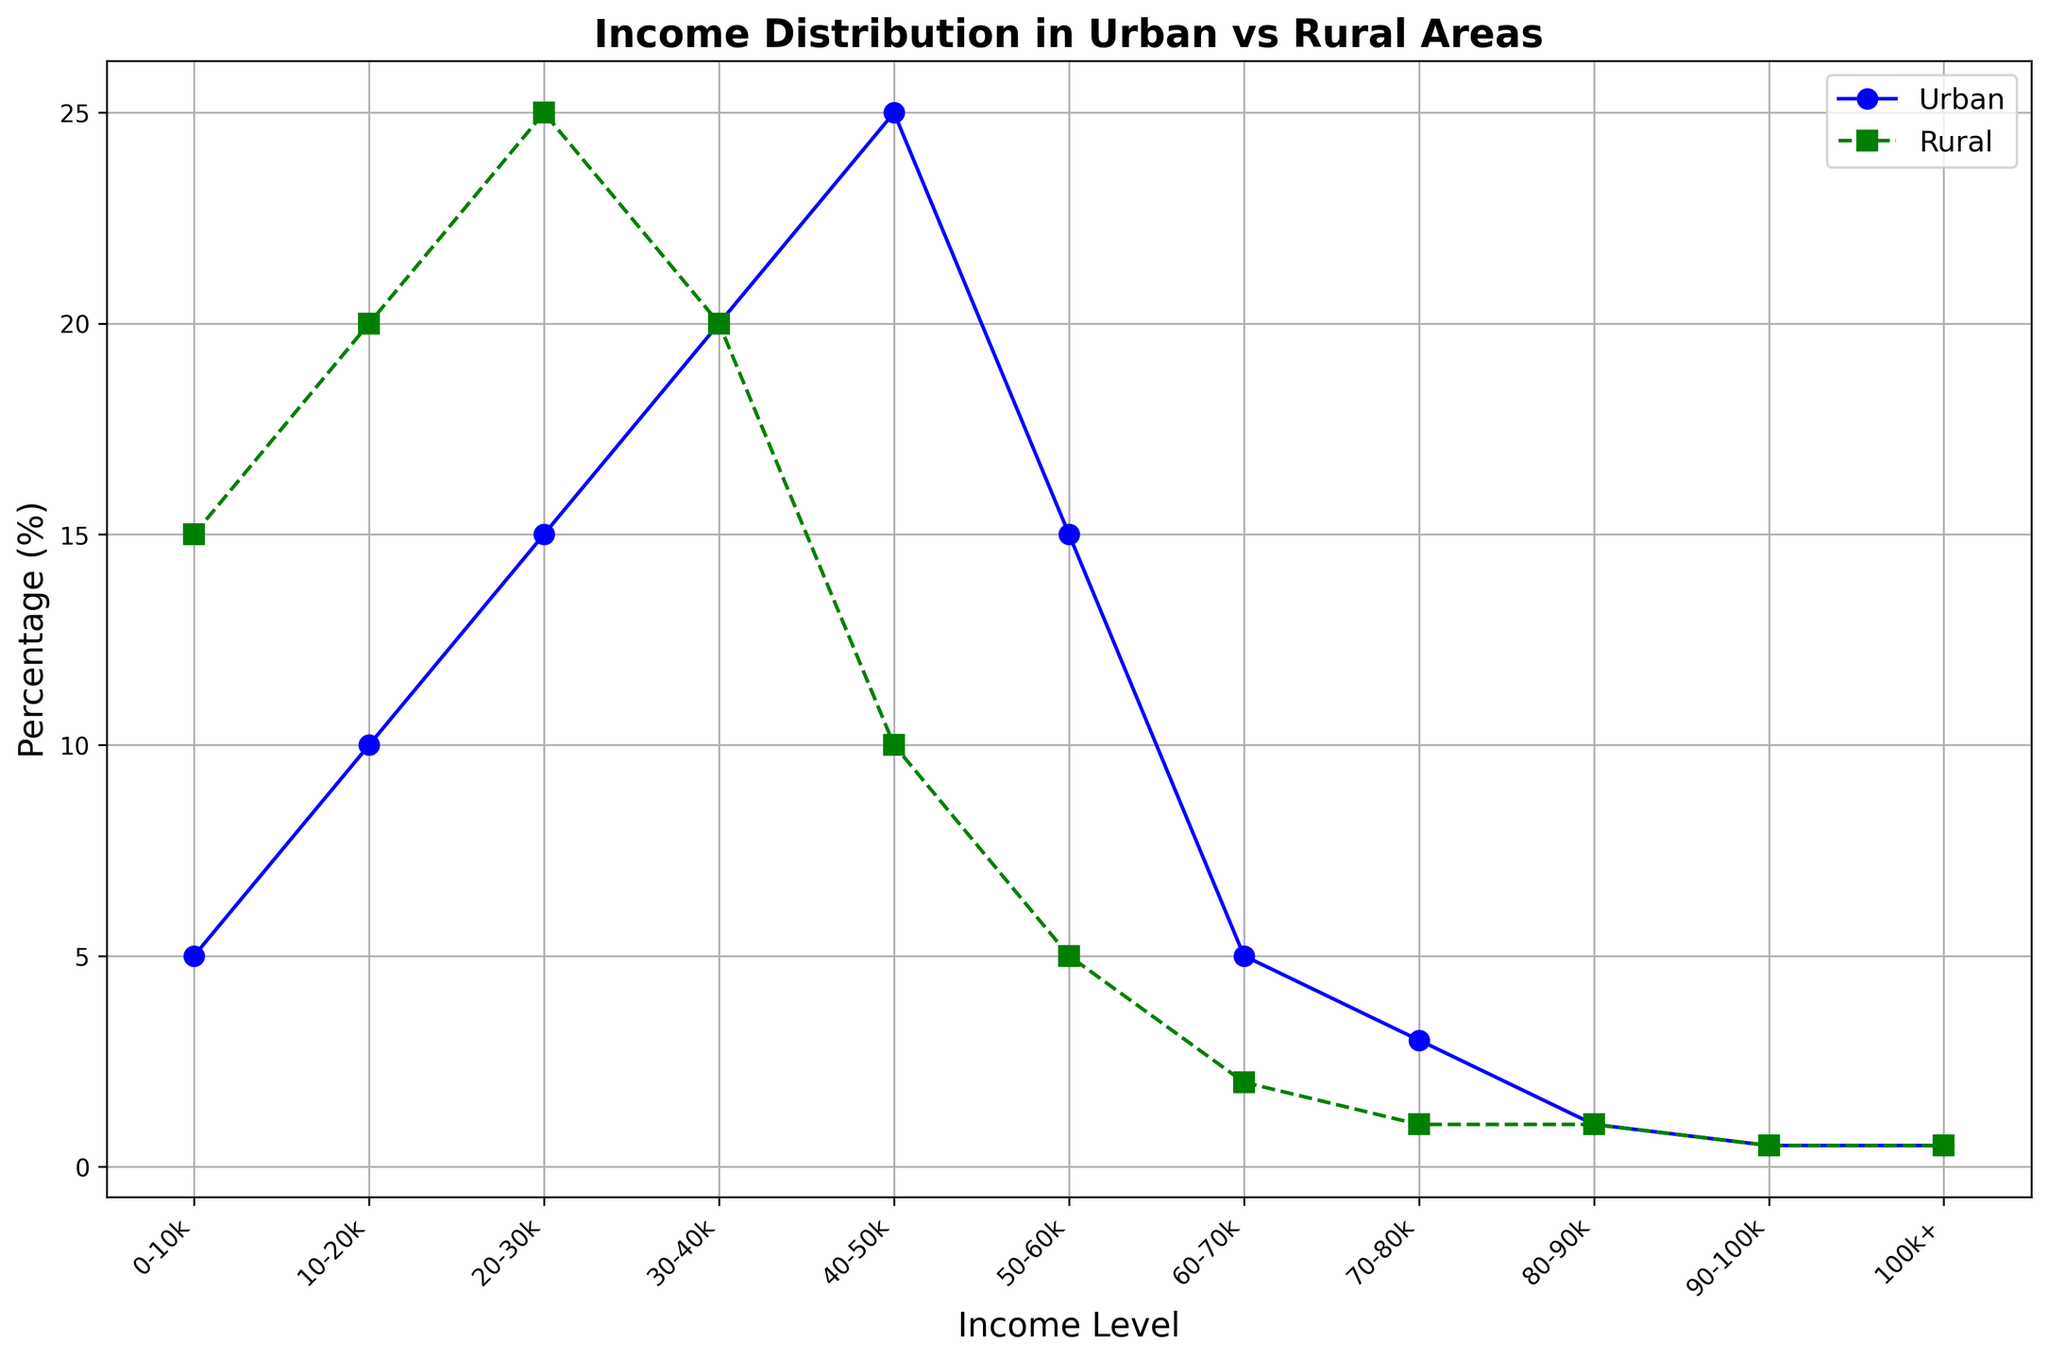What is the difference in percentage of households earning between 0-10k in Urban and Rural areas? To find the difference, subtract the percentage of Urban households from the percentage of Rural households in the 0-10k income level. Urban has 5%, and Rural has 15%. So, 15% - 5% = 10%.
Answer: 10% Which area has a higher percentage of households earning between 40-50k, and by how much? Compare the percentages of households at the 40-50k income level for both areas. Urban has 25%, and Rural has 10%. The difference is 25% - 10% = 15%.
Answer: Urban by 15% Which income level has the highest percentage of households in Urban areas, and what is that percentage? Look for the peak percentage in the Urban area. The highest percentage is at the 40-50k level with 25%.
Answer: 40-50k with 25% At which income levels do Urban and Rural areas have the same percentage of households, and what is that percentage? Identify the income levels where both Urban and Rural percentages are equal. The matching levels are 90-100k and 100k+, where both have 0.5%.
Answer: 90-100k and 100k+ with 0.5% What is the average percentage of households earning above 50k in Urban areas? To find the average percentage, add the percentages of all income levels above 50k in Urban areas and divide by the number of these levels. Percentages for 50-60k, 60-70k, 70-80k, 80-90k, 90-100k, and 100k+ are 15%, 5%, 3%, 1%, 0.5%, and 0.5%, respectively. Sum: 15 + 5 + 3 + 1 + 0.5 + 0.5 = 25%. Average = 25% / 6 ≈ 4.17%.
Answer: 4.17% What is the sum of the percentages of households earning between 30-40k and 40-50k in Urban areas? Add the percentages of the 30-40k and 40-50k income levels in Urban areas. 20% (30-40k) + 25% (40-50k) = 45%.
Answer: 45% Which area has a lower percentage of households earning between 70-80k, and what is that percentage? Compare the percentages at the 70-80k income level. Urban has 3%, and Rural has 1%. Rural's percentage is lower.
Answer: Rural with 1% 